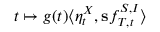<formula> <loc_0><loc_0><loc_500><loc_500>t \mapsto g ( t ) \langle \eta _ { t } ^ { X } , s f _ { T , t } ^ { S , I } \rangle</formula> 